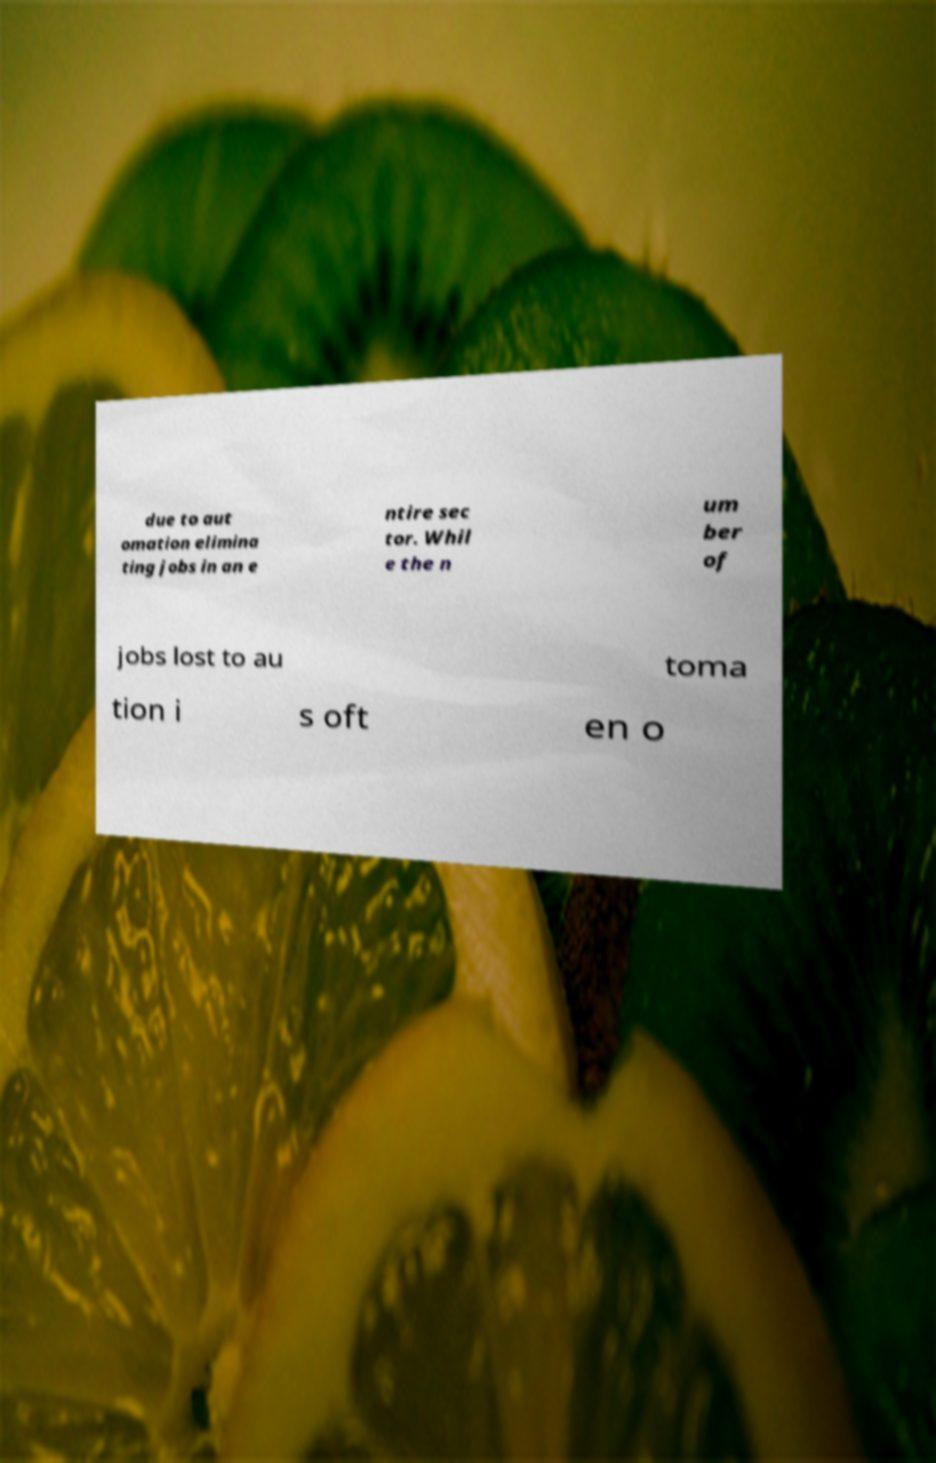Please read and relay the text visible in this image. What does it say? due to aut omation elimina ting jobs in an e ntire sec tor. Whil e the n um ber of jobs lost to au toma tion i s oft en o 